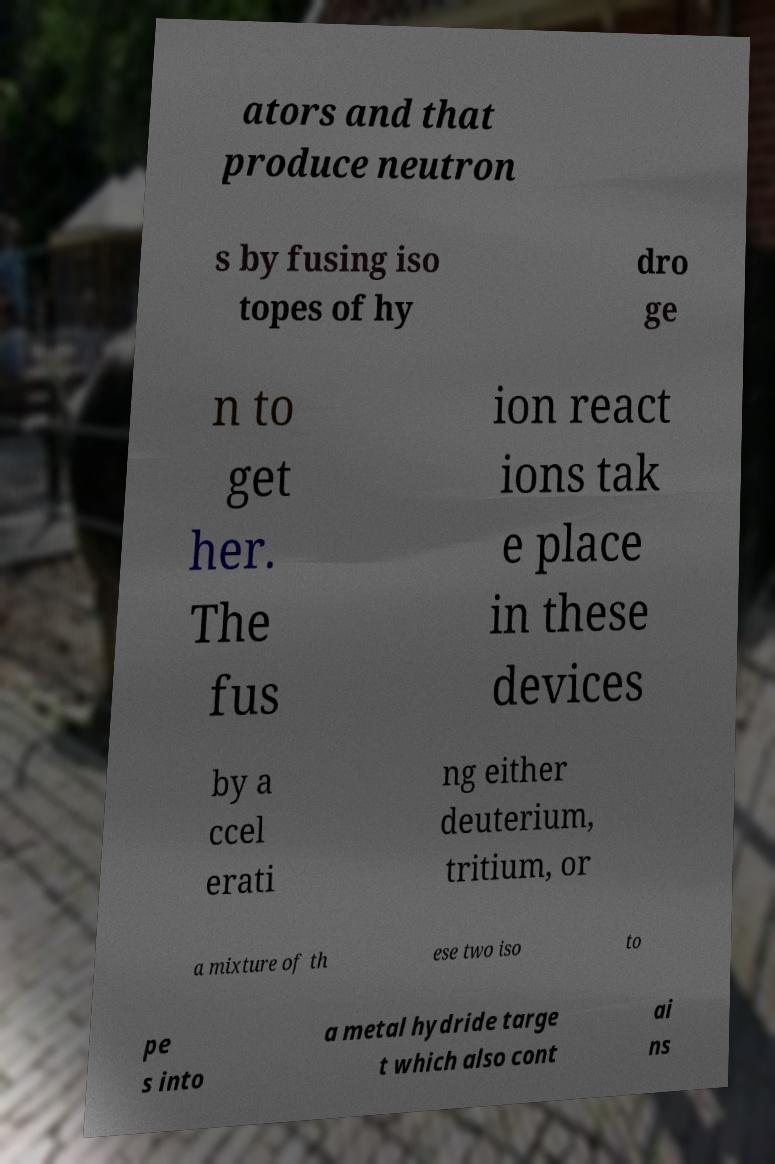What messages or text are displayed in this image? I need them in a readable, typed format. ators and that produce neutron s by fusing iso topes of hy dro ge n to get her. The fus ion react ions tak e place in these devices by a ccel erati ng either deuterium, tritium, or a mixture of th ese two iso to pe s into a metal hydride targe t which also cont ai ns 